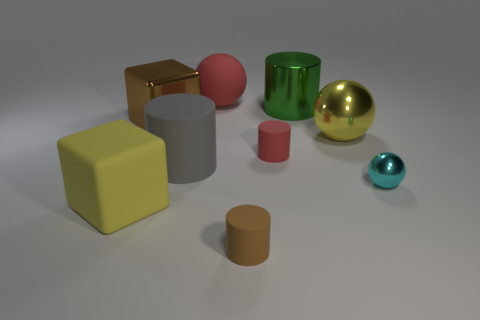Add 1 large brown matte things. How many objects exist? 10 Subtract all yellow balls. How many balls are left? 2 Subtract all metal balls. How many balls are left? 1 Subtract all blocks. How many objects are left? 7 Subtract 1 cubes. How many cubes are left? 1 Subtract all green balls. Subtract all gray cylinders. How many balls are left? 3 Subtract all blue cylinders. How many green blocks are left? 0 Add 2 brown cylinders. How many brown cylinders exist? 3 Subtract 1 red balls. How many objects are left? 8 Subtract all tiny blue metal cylinders. Subtract all shiny blocks. How many objects are left? 8 